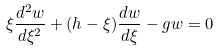<formula> <loc_0><loc_0><loc_500><loc_500>\xi \frac { d ^ { 2 } w } { d \xi ^ { 2 } } + ( h - \xi ) \frac { d w } { d \xi } - g w = 0</formula> 